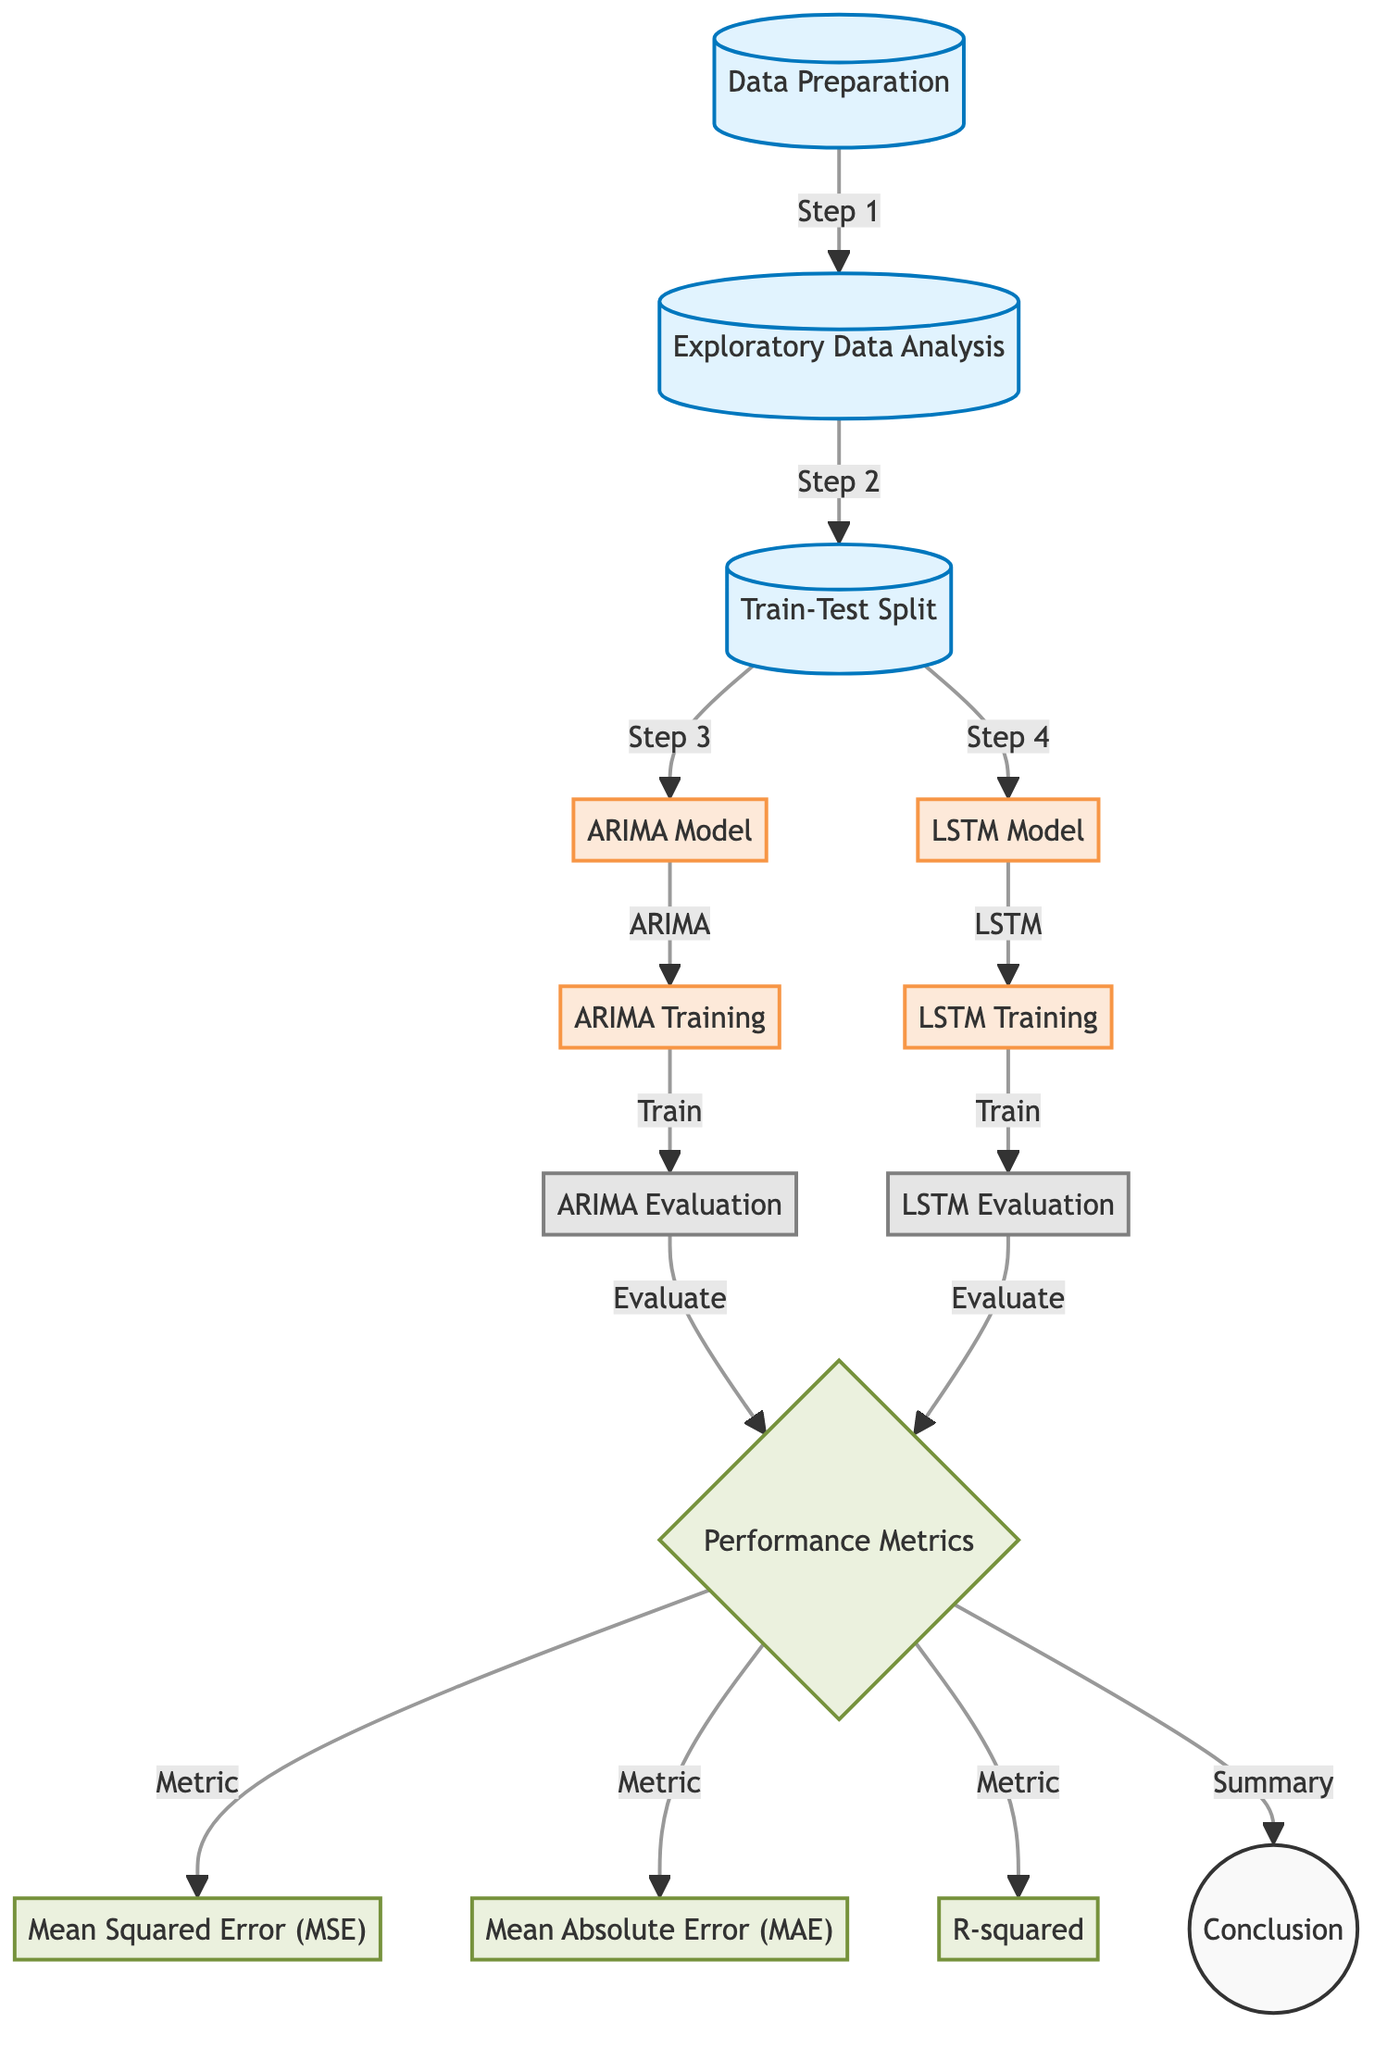What is the first step in the diagram? The first step indicated in the diagram is "Data Preparation." This can be seen as the starting point before any analysis or model application is performed.
Answer: Data Preparation How many performance metrics are evaluated? The diagram lists three performance metrics: Mean Squared Error (MSE), Mean Absolute Error (MAE), and R-squared. Each of these metrics is connected to the "Performance Metrics" node, confirming their count.
Answer: Three Which model is trained after ARIMA? The diagram shows that after the "ARIMA Training" node, the next node is "ARIMA Evaluation." However, it is important to note that "LSTM Training" is the next model training step proceeding from "Train-Test Split" instead of following after ARIMA. Therefore, it is specific to how the flow is structured.
Answer: LSTM What do the nodes "ARIMA" and "LSTM" represent? Both nodes represent different time series forecasting models: "ARIMA Model" signifies the statistical approach, and "LSTM Model" indicates the deep learning method, demonstrating the comparison aspect of the diagram.
Answer: Different models What is the final node in the diagram? The final node in the diagram is labeled as "Conclusion." It is the last step following the performance metrics evaluation, summarizing the results from both models.
Answer: Conclusion Which step comes after exploratory analysis? According to the diagram flow, "Train-Test Split" follows after "Exploratory Data Analysis." This step is crucial for splitting the prepared data into training and testing sets prior to model training.
Answer: Train-Test Split What type of diagram is this? The diagram is specifically a "Machine Learning Diagram" focused on comparing time series forecasting techniques, hence it is structured to outline data preparation, model training, evaluation, and performance metrics.
Answer: Machine Learning Diagram In what stage do performance metrics become available? Performance metrics are evaluated after both the "ARIMA Evaluation" and "LSTM Evaluation" stages. The diagram indicates that performance metrics are not introduced until after both models have undergone their training and evaluation phase.
Answer: After evaluation How are the performance metrics categorized in this diagram? The performance metrics are categorized into three types linked to the "Performance Metrics" node: Mean Squared Error (MSE), Mean Absolute Error (MAE), and R-squared. Each metric specifically assesses model performance to aid in comparison.
Answer: Three types 